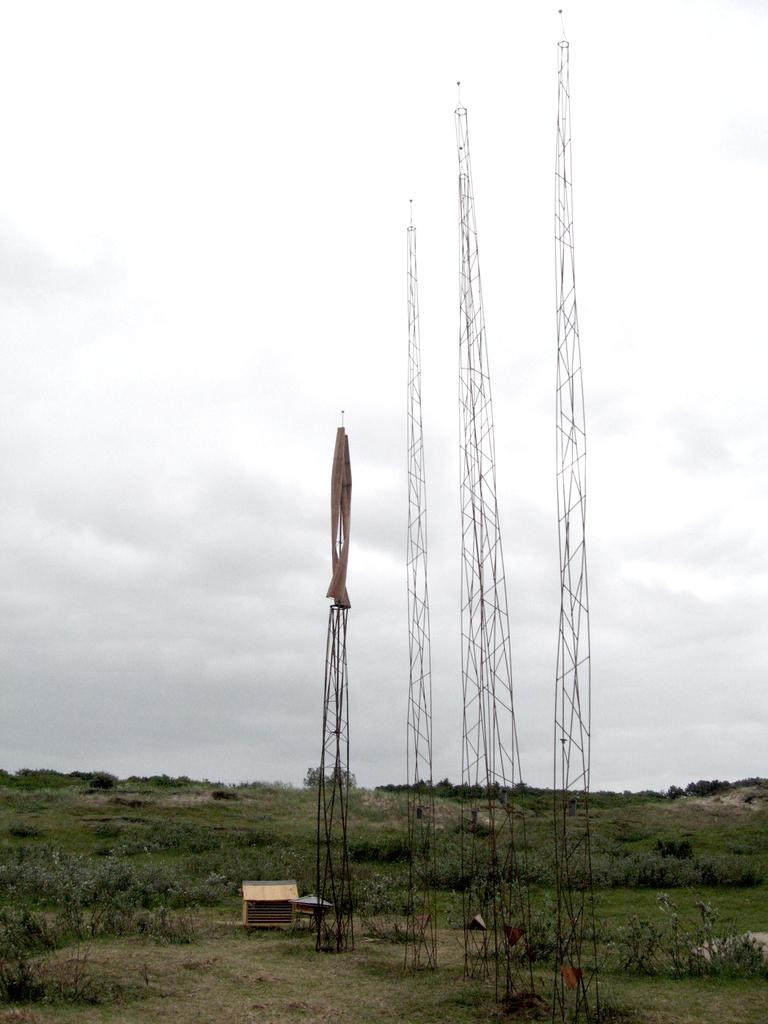What is the main subject in the center of the image? There are towers in the center of the image. What are the towers made of? The towers are made up of iron bars. What can be seen at the bottom of the image? There are plants and grass at the bottom of the image. What is visible in the background of the image? The sky is visible in the background of the image. What type of drink can be seen in the image? There is no drink present in the image. What color are the leaves on the plants in the image? There are no leaves mentioned in the provided facts, as the plants are described as being at the bottom of the image. 